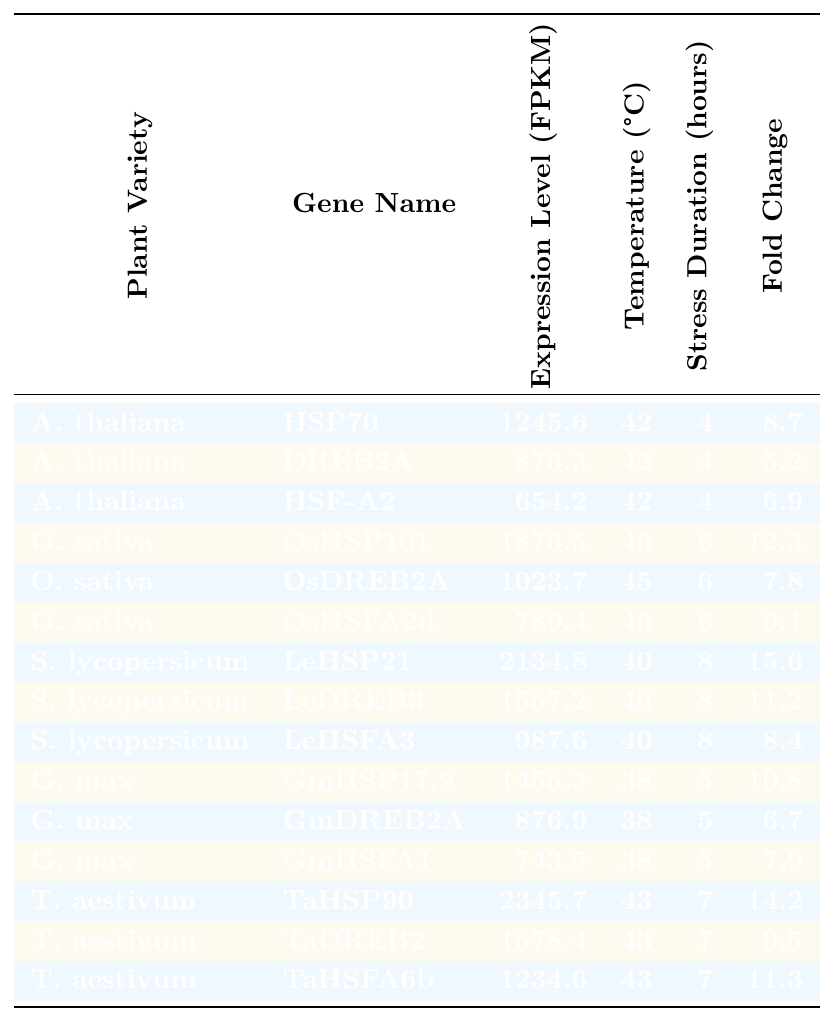What is the expression level of HSP70 in Arabidopsis thaliana? The table shows that the expression level of HSP70 for Arabidopsis thaliana is listed as 1245.6 FPKM.
Answer: 1245.6 FPKM Which plant variety has the highest expression level? By examining the expression levels in the table, Solanum lycopersicum with the gene LeHSP21 has the highest expression level at 2134.8 FPKM.
Answer: Solanum lycopersicum (LeHSP21) What is the average expression level of genes for Oryza sativa? The expression levels for Oryza sativa are 1876.5, 1023.7, and 789.4 FPKM. The sum is 2689.6 FPKM, and there are 3 values; thus, the average is 2689.6/3 = 896.53 FPKM.
Answer: 896.53 FPKM Is the fold change of LeHSP21 greater than 10? According to the table, the fold change for LeHSP21 is 15.6, which is greater than 10.
Answer: Yes What is the fold change difference between the highest and lowest fold changes in Triticum aestivum? The highest fold change in Triticum aestivum is 14.2 (TaHSP90) and the lowest is 9.5 (TaDREB2). The difference is 14.2 - 9.5 = 4.7.
Answer: 4.7 How many hours of stress were applied to Glycine max varieties? The stress duration for all Glycine max varieties listed is 5 hours.
Answer: 5 hours Which gene in Arabidopsis thaliana has the lowest expression level? Evaluating the expression levels in the table, HSF-A2 has the lowest expression level at 654.2 FPKM among Arabidopsis thaliana genes.
Answer: HSF-A2 (654.2 FPKM) What is the temperature during the stress tests for Solanum lycopersicum? The table indicates that the temperature during stress tests for Solanum lycopersicum is consistently 40 °C.
Answer: 40 °C If we combine the expression levels of HSP genes across all plant varieties, which variety has the highest total? The total expression for HSP genes (HSP70 for A. thaliana, OsHSP101 for O. sativa, LeHSP21 for S. lycopersicum, GmHSP17.9 for G. max, TaHSP90 for T. aestivum) is 1245.6 + 1876.5 + 2134.8 + 1456.3 + 2345.7 = 10858.2 FPKM. TaHSP90 contributes the highest single value (2345.7 FPKM).
Answer: T. aestivum (TaHSP90) Which variety demonstrates a fold change of 9.1 or greater? From the table, the varieties showing a fold change of 9.1 or greater are Oryza sativa (OsHSP101, 12.3), Solanum lycopersicum (LeHSP21, 15.6), and Triticum aestivum (TaHSP90, 14.2).
Answer: Oryza sativa, Solanum lycopersicum, Triticum aestivum 